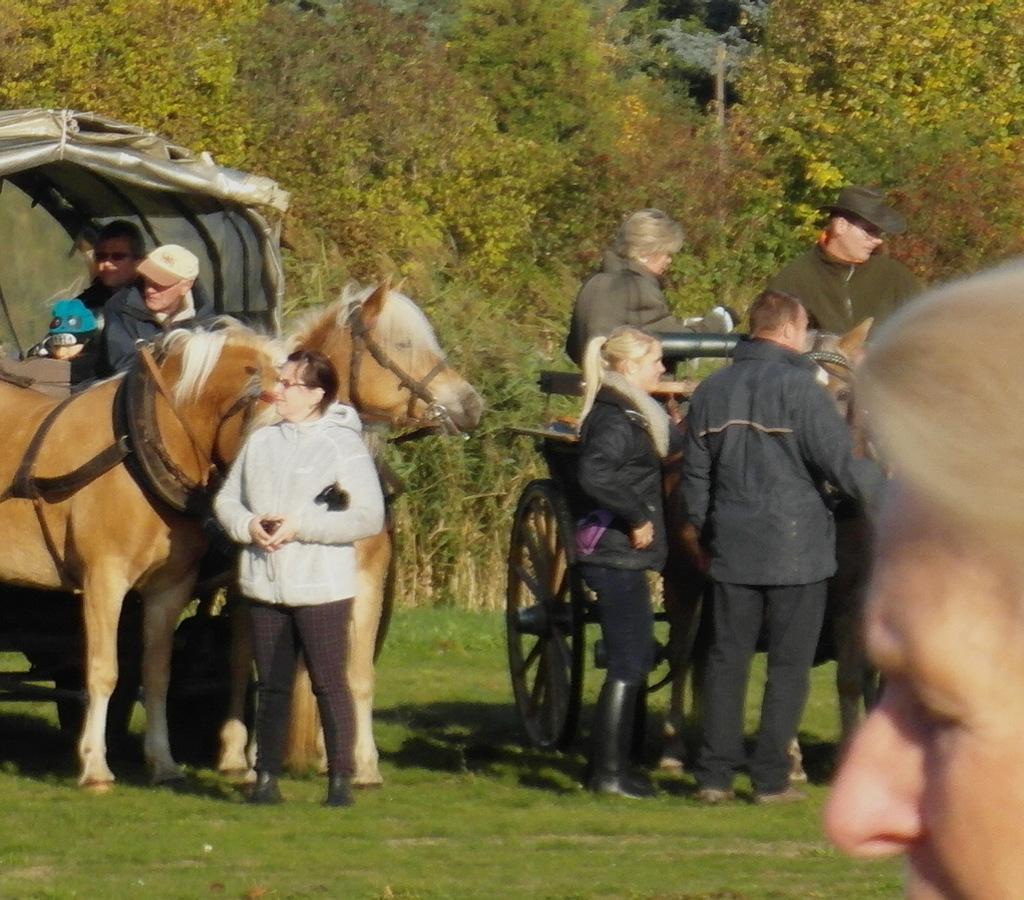Could you give a brief overview of what you see in this image? In this image I see few persons who are sitting in the cart and I see 3 horses and few people who are standing on the grass. In the background I see the trees. 